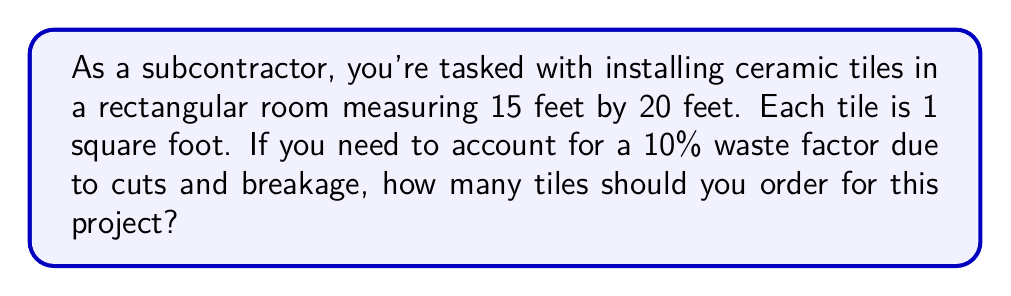Provide a solution to this math problem. To solve this problem, we'll follow these steps:

1. Calculate the total area of the room:
   $$\text{Area} = \text{Length} \times \text{Width}$$
   $$\text{Area} = 15 \text{ ft} \times 20 \text{ ft} = 300 \text{ sq ft}$$

2. Calculate the number of tiles needed without waste:
   Since each tile is 1 square foot, the number of tiles equals the area.
   $$\text{Tiles without waste} = 300$$

3. Calculate the waste factor:
   10% of 300 is:
   $$0.10 \times 300 = 30$$

4. Add the waste factor to the initial number of tiles:
   $$\text{Total tiles needed} = \text{Tiles without waste} + \text{Waste factor}$$
   $$\text{Total tiles needed} = 300 + 30 = 330$$

5. Round up to the nearest whole number:
   Since we can't order a fraction of a tile, we round up to 330 tiles.
Answer: You should order 330 tiles for this project. 